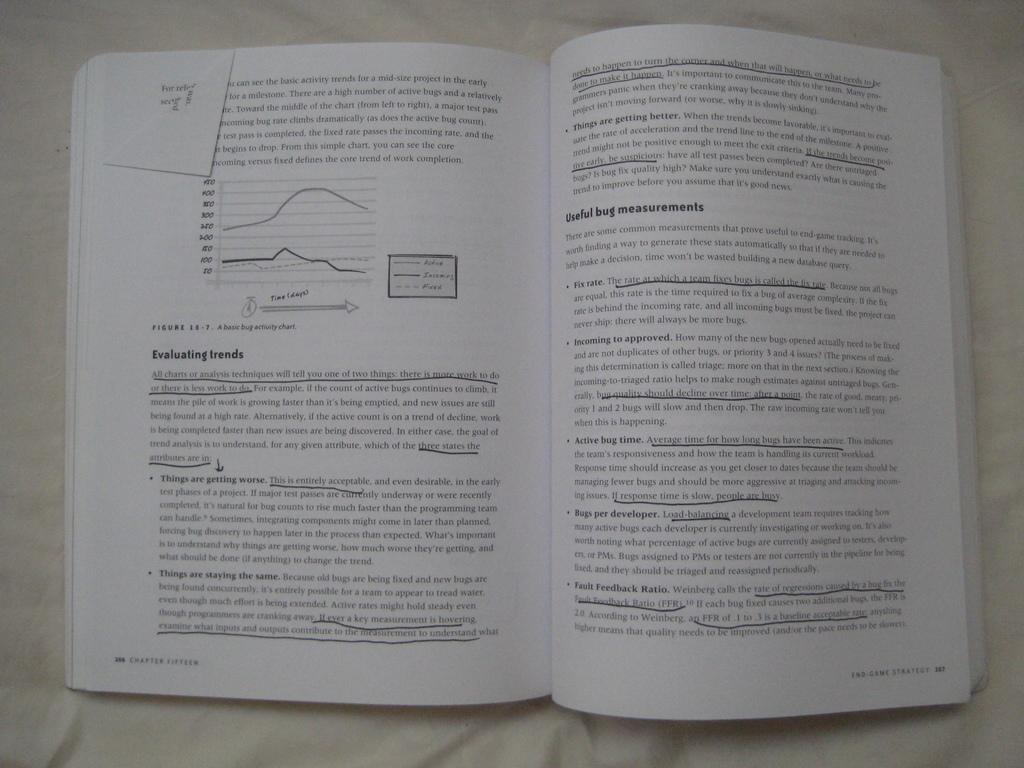<image>
Write a terse but informative summary of the picture. The Book 'End Game Strategy is opened to Chapter Fifteen with multiple sentences underlined on the pages. 